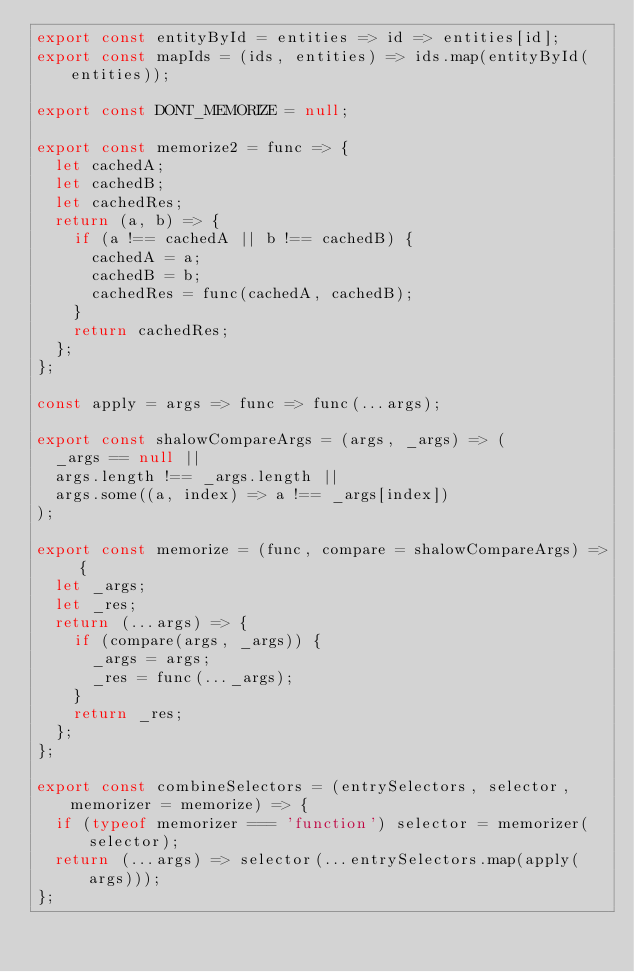<code> <loc_0><loc_0><loc_500><loc_500><_JavaScript_>export const entityById = entities => id => entities[id];
export const mapIds = (ids, entities) => ids.map(entityById(entities));

export const DONT_MEMORIZE = null;

export const memorize2 = func => {
  let cachedA;
  let cachedB;
  let cachedRes;
  return (a, b) => {
    if (a !== cachedA || b !== cachedB) {
      cachedA = a;
      cachedB = b;
      cachedRes = func(cachedA, cachedB);
    }
    return cachedRes;
  };
};

const apply = args => func => func(...args);

export const shalowCompareArgs = (args, _args) => (
  _args == null ||
  args.length !== _args.length ||
  args.some((a, index) => a !== _args[index])
);

export const memorize = (func, compare = shalowCompareArgs) => {
  let _args;
  let _res;
  return (...args) => {
    if (compare(args, _args)) {
      _args = args;
      _res = func(..._args);
    }
    return _res;
  };
};

export const combineSelectors = (entrySelectors, selector, memorizer = memorize) => {
  if (typeof memorizer === 'function') selector = memorizer(selector);
  return (...args) => selector(...entrySelectors.map(apply(args)));
};
</code> 